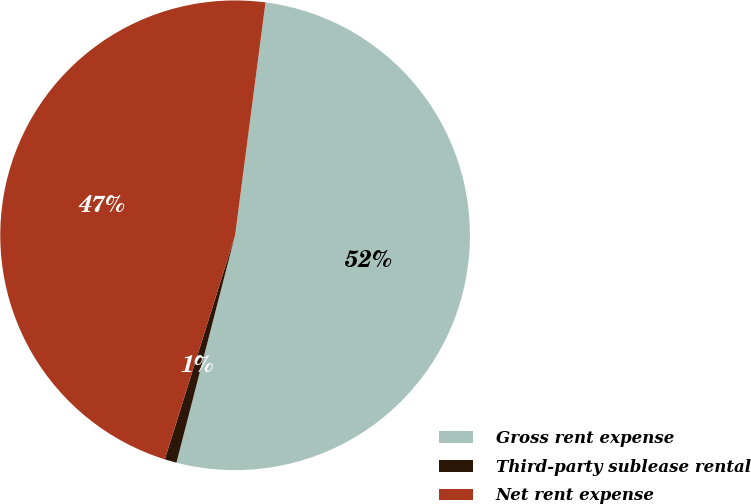Convert chart. <chart><loc_0><loc_0><loc_500><loc_500><pie_chart><fcel>Gross rent expense<fcel>Third-party sublease rental<fcel>Net rent expense<nl><fcel>51.95%<fcel>0.82%<fcel>47.23%<nl></chart> 